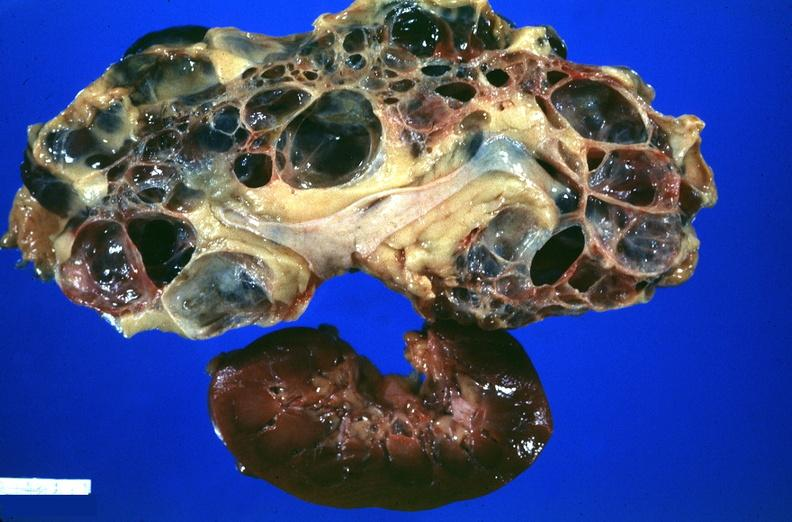where is this?
Answer the question using a single word or phrase. Urinary 